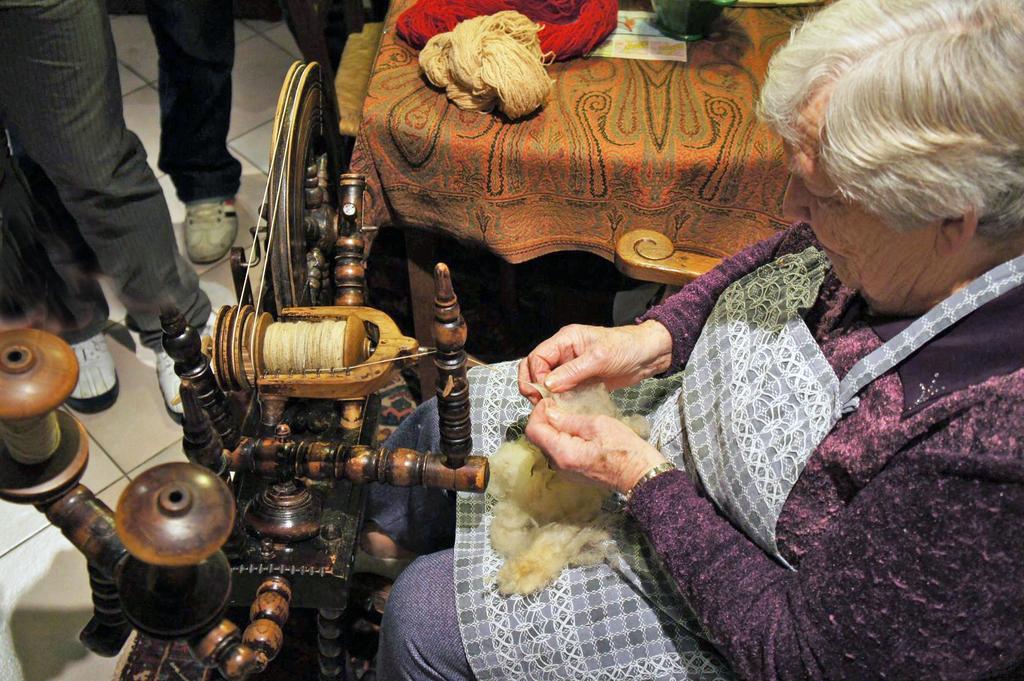Could you give a brief overview of what you see in this image? In this image there is a woman sitting on a chair in the center holding a white colour object in her hand. In front of the woman there is a wooden stand and there are legs visible of the person on the left side. At the top there is a bed and there are some objects which are red and white in colour kept on the bed. 